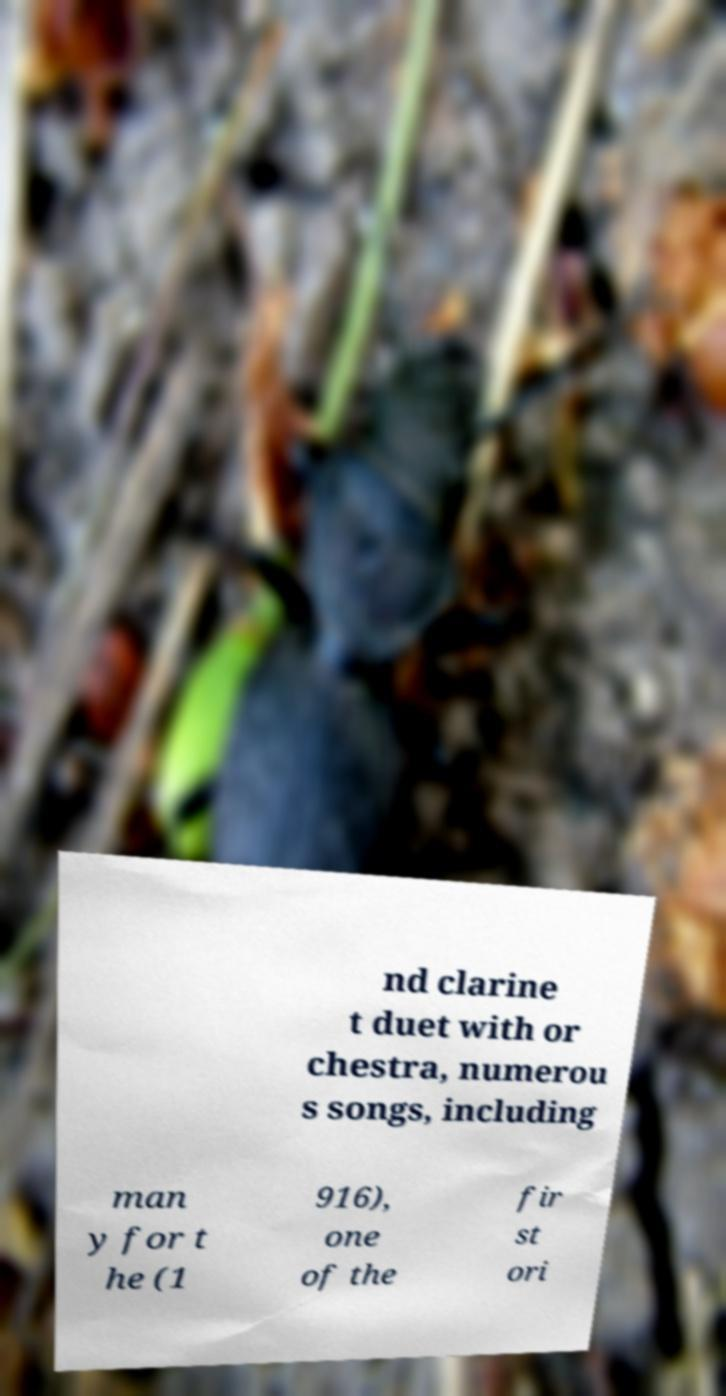I need the written content from this picture converted into text. Can you do that? nd clarine t duet with or chestra, numerou s songs, including man y for t he (1 916), one of the fir st ori 